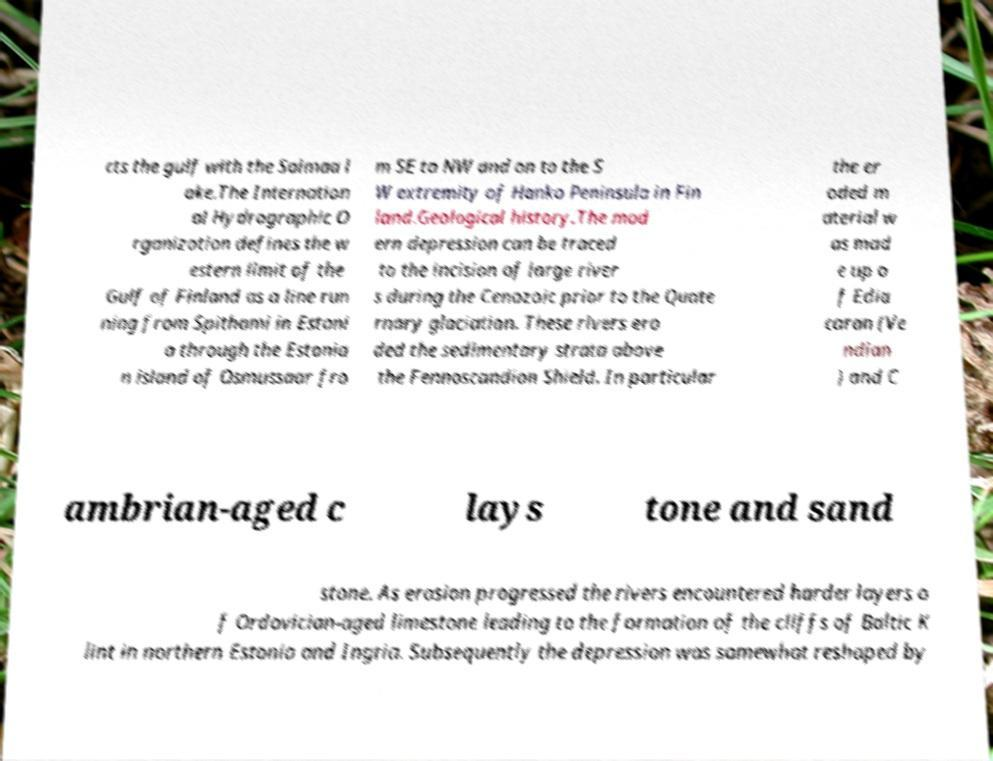I need the written content from this picture converted into text. Can you do that? cts the gulf with the Saimaa l ake.The Internation al Hydrographic O rganization defines the w estern limit of the Gulf of Finland as a line run ning from Spithami in Estoni a through the Estonia n island of Osmussaar fro m SE to NW and on to the S W extremity of Hanko Peninsula in Fin land.Geological history.The mod ern depression can be traced to the incision of large river s during the Cenozoic prior to the Quate rnary glaciation. These rivers ero ded the sedimentary strata above the Fennoscandian Shield. In particular the er oded m aterial w as mad e up o f Edia caran (Ve ndian ) and C ambrian-aged c lays tone and sand stone. As erosion progressed the rivers encountered harder layers o f Ordovician-aged limestone leading to the formation of the cliffs of Baltic K lint in northern Estonia and Ingria. Subsequently the depression was somewhat reshaped by 